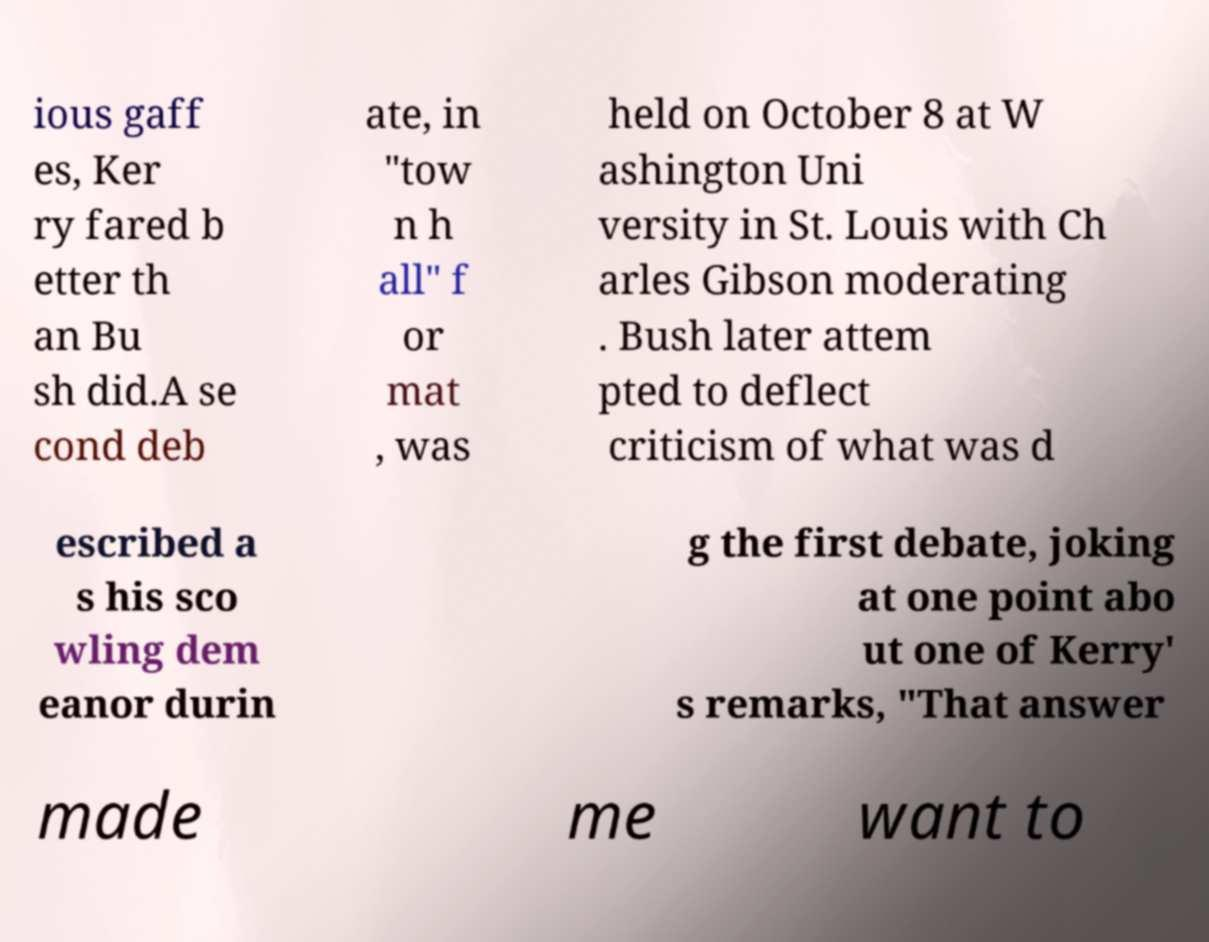There's text embedded in this image that I need extracted. Can you transcribe it verbatim? ious gaff es, Ker ry fared b etter th an Bu sh did.A se cond deb ate, in "tow n h all" f or mat , was held on October 8 at W ashington Uni versity in St. Louis with Ch arles Gibson moderating . Bush later attem pted to deflect criticism of what was d escribed a s his sco wling dem eanor durin g the first debate, joking at one point abo ut one of Kerry' s remarks, "That answer made me want to 